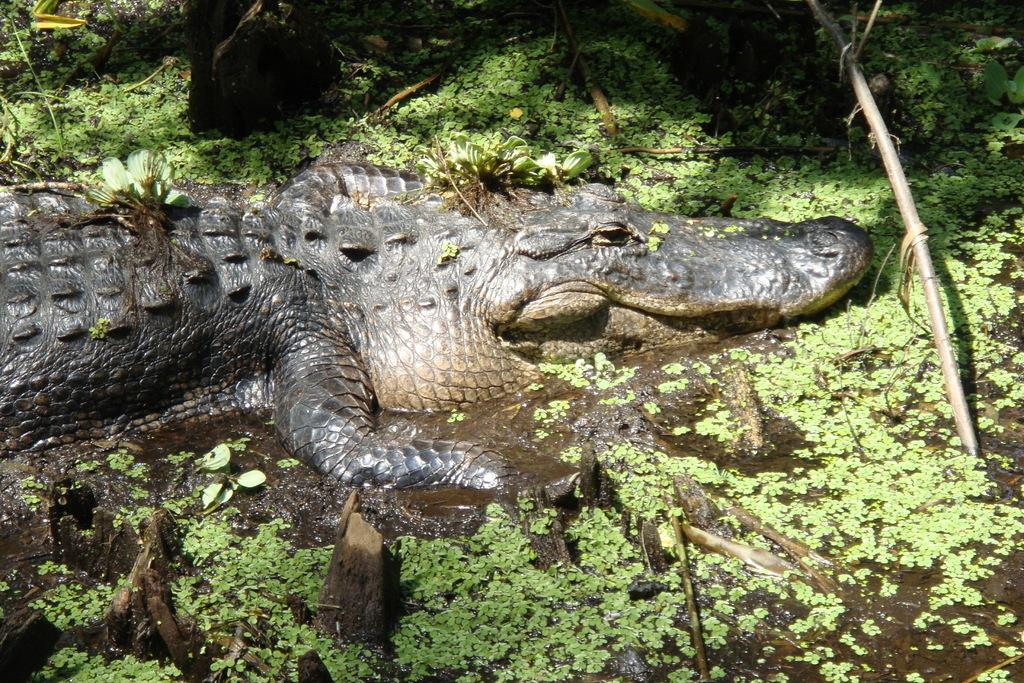What animal is present in the image? There is a crocodile in the image. What is at the bottom of the image? There is water at the bottom of the image. What can be seen floating in the water? There are logs visible in the water. What type of vegetation is present in the image? There is grass in the image. What type of cracker is floating on the water in the image? There is no cracker present in the image; it features a crocodile, water, logs, and grass. How does the drain affect the water in the image? There is no drain present in the image, so its effect on the water cannot be determined. 